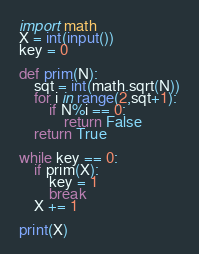<code> <loc_0><loc_0><loc_500><loc_500><_Python_>import math
X = int(input())
key = 0

def prim(N):
    sqt = int(math.sqrt(N))
    for i in range(2,sqt+1):
        if N%i == 0:
            return False
    return True

while key == 0:
    if prim(X):
        key = 1
        break
    X += 1

print(X)</code> 